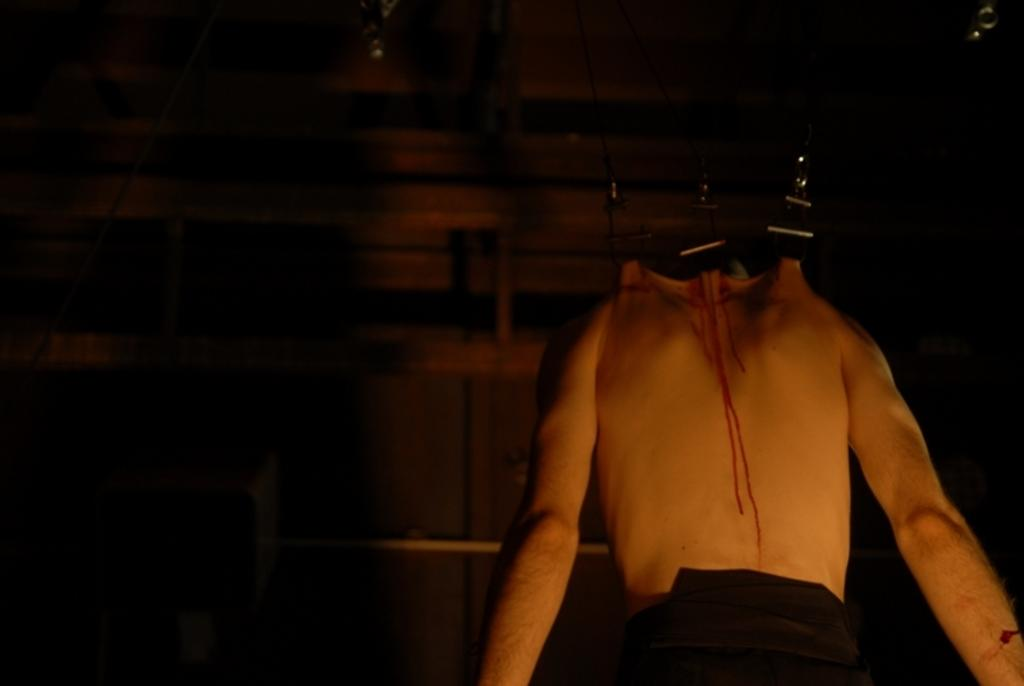What is the main subject of the image? The main subject of the image is a dead man. Can you describe the condition of the dead man? There is blood on the back of the dead man. What can be seen in the background of the image? There is a wooden wall in the background of the image. How many boys are playing the guitar in the image? There are no boys or guitars present in the image. What type of unit is being used to measure the distance between the dead man and the wooden wall? There is no unit or measurement mentioned in the image. 